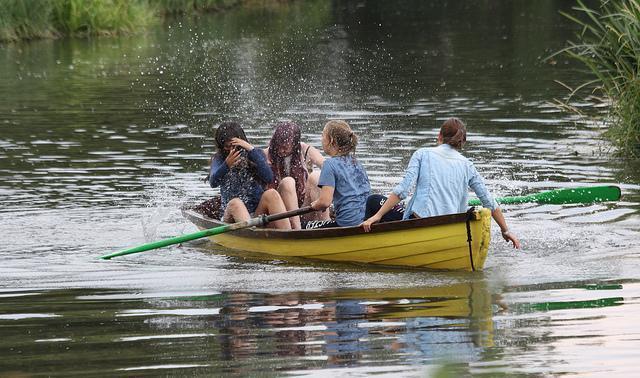What is the green item?
Answer the question by selecting the correct answer among the 4 following choices.
Options: Frog, antelope, lizard, oar. Oar. 